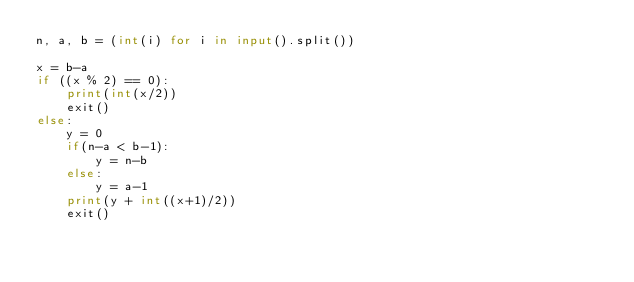Convert code to text. <code><loc_0><loc_0><loc_500><loc_500><_Python_>n, a, b = (int(i) for i in input().split())

x = b-a
if ((x % 2) == 0):
    print(int(x/2))
    exit()
else:
    y = 0
    if(n-a < b-1):
        y = n-b
    else:
        y = a-1
    print(y + int((x+1)/2))
    exit()
</code> 